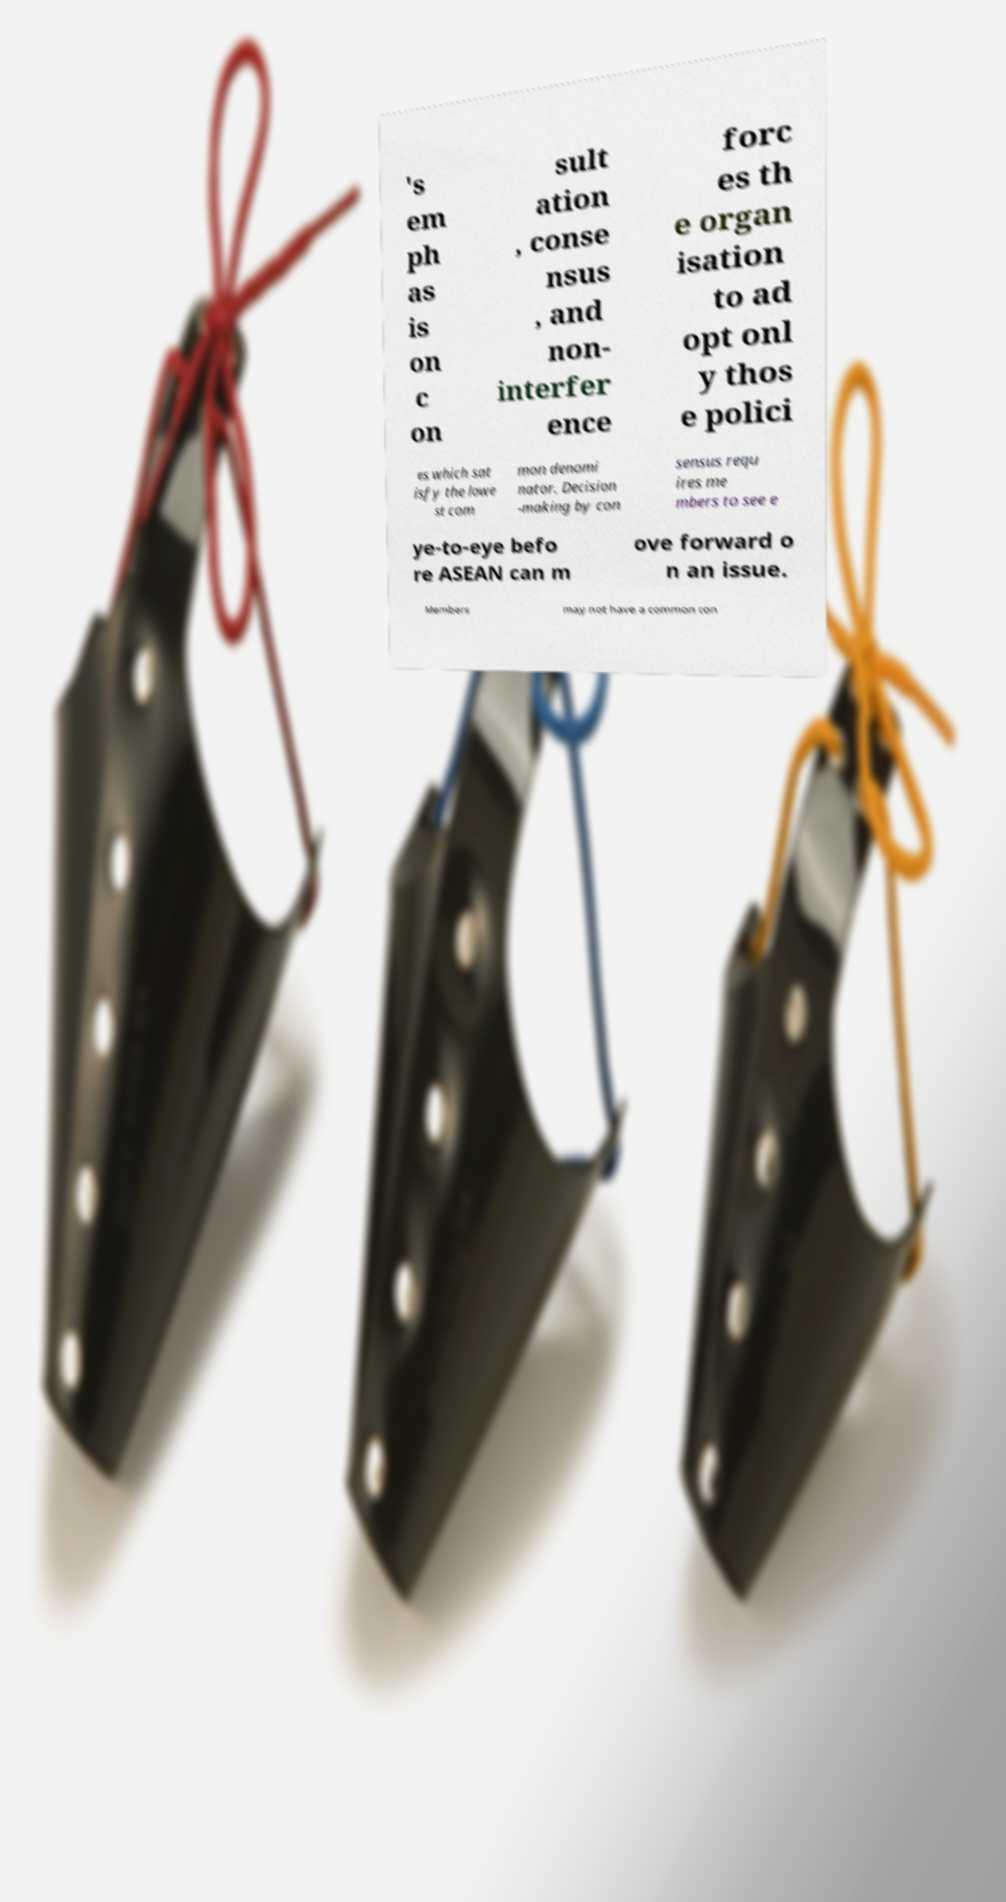Could you assist in decoding the text presented in this image and type it out clearly? 's em ph as is on c on sult ation , conse nsus , and non- interfer ence forc es th e organ isation to ad opt onl y thos e polici es which sat isfy the lowe st com mon denomi nator. Decision -making by con sensus requ ires me mbers to see e ye-to-eye befo re ASEAN can m ove forward o n an issue. Members may not have a common con 